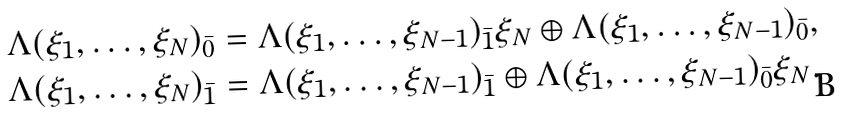<formula> <loc_0><loc_0><loc_500><loc_500>& \Lambda ( \xi _ { 1 } , \dots , \xi _ { N } ) _ { \bar { 0 } } = \Lambda ( \xi _ { 1 } , \dots , \xi _ { N - 1 } ) _ { \bar { 1 } } \xi _ { N } \oplus \Lambda ( \xi _ { 1 } , \dots , \xi _ { N - 1 } ) _ { \bar { 0 } } , \\ & \Lambda ( \xi _ { 1 } , \dots , \xi _ { N } ) _ { \bar { 1 } } = \Lambda ( \xi _ { 1 } , \dots , \xi _ { N - 1 } ) _ { \bar { 1 } } \oplus \Lambda ( \xi _ { 1 } , \dots , \xi _ { N - 1 } ) _ { \bar { 0 } } \xi _ { N } .</formula> 